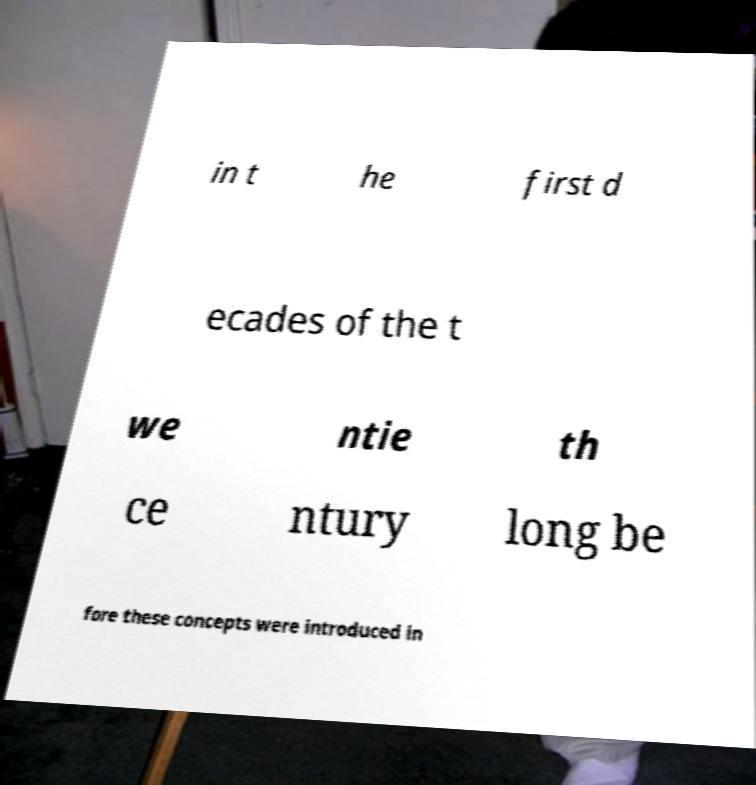For documentation purposes, I need the text within this image transcribed. Could you provide that? in t he first d ecades of the t we ntie th ce ntury long be fore these concepts were introduced in 